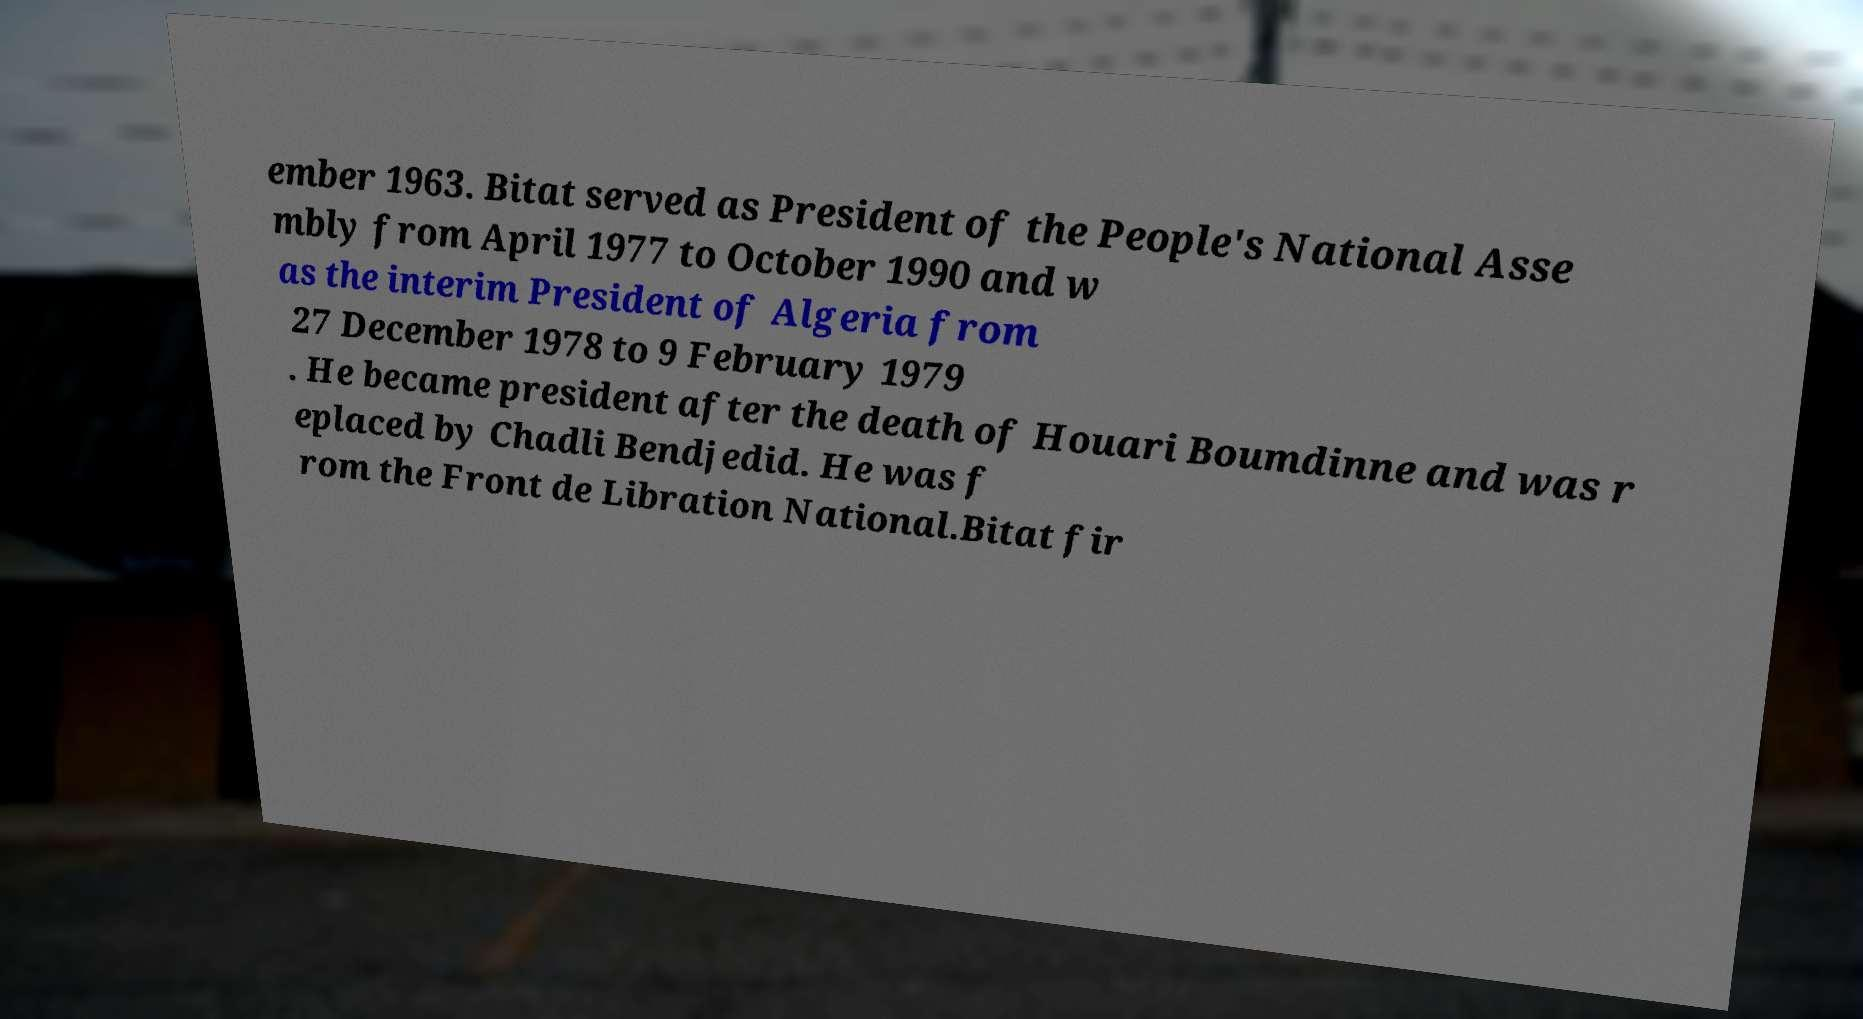Please identify and transcribe the text found in this image. ember 1963. Bitat served as President of the People's National Asse mbly from April 1977 to October 1990 and w as the interim President of Algeria from 27 December 1978 to 9 February 1979 . He became president after the death of Houari Boumdinne and was r eplaced by Chadli Bendjedid. He was f rom the Front de Libration National.Bitat fir 